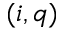<formula> <loc_0><loc_0><loc_500><loc_500>( i , q )</formula> 